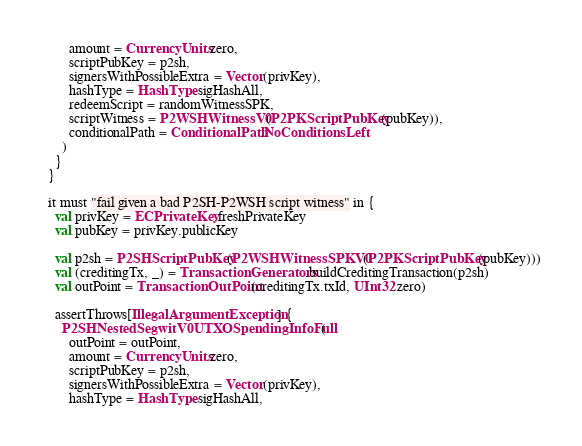<code> <loc_0><loc_0><loc_500><loc_500><_Scala_>        amount = CurrencyUnits.zero,
        scriptPubKey = p2sh,
        signersWithPossibleExtra = Vector(privKey),
        hashType = HashType.sigHashAll,
        redeemScript = randomWitnessSPK,
        scriptWitness = P2WSHWitnessV0(P2PKScriptPubKey(pubKey)),
        conditionalPath = ConditionalPath.NoConditionsLeft
      )
    }
  }

  it must "fail given a bad P2SH-P2WSH script witness" in {
    val privKey = ECPrivateKey.freshPrivateKey
    val pubKey = privKey.publicKey

    val p2sh = P2SHScriptPubKey(P2WSHWitnessSPKV0(P2PKScriptPubKey(pubKey)))
    val (creditingTx, _) = TransactionGenerators.buildCreditingTransaction(p2sh)
    val outPoint = TransactionOutPoint(creditingTx.txId, UInt32.zero)

    assertThrows[IllegalArgumentException] {
      P2SHNestedSegwitV0UTXOSpendingInfoFull(
        outPoint = outPoint,
        amount = CurrencyUnits.zero,
        scriptPubKey = p2sh,
        signersWithPossibleExtra = Vector(privKey),
        hashType = HashType.sigHashAll,</code> 